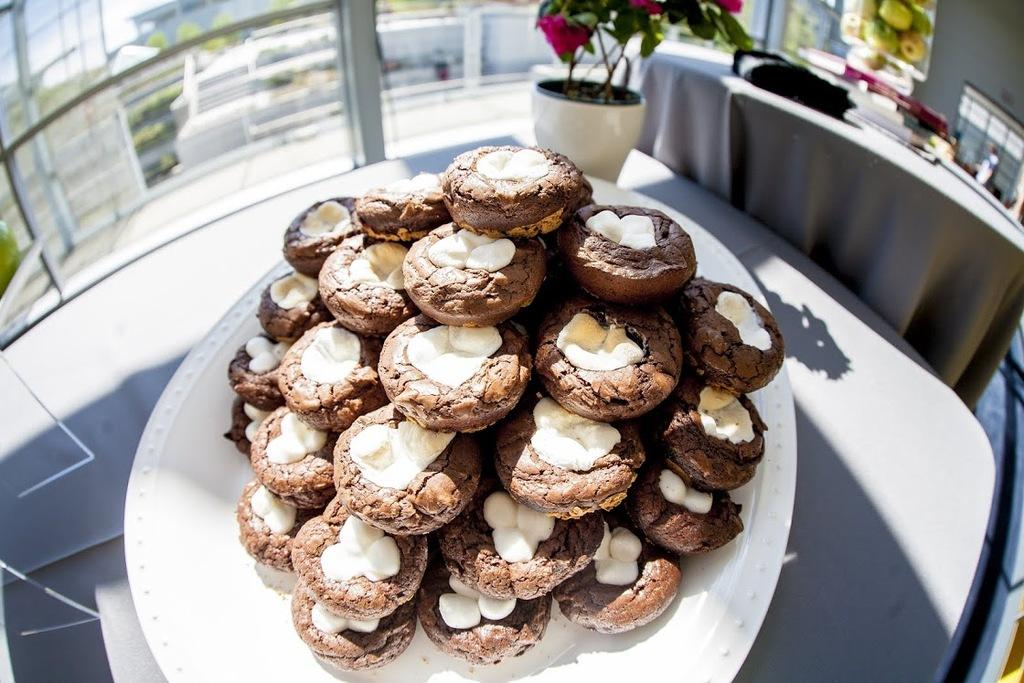What is on the serving plate in the image? The serving plate has cookies placed in rows on it. What else can be seen in the image besides the serving plate? There is a houseplant, a picture on the wall, and tables in the image. Can you describe the arrangement of the cookies on the serving plate? The cookies are placed in rows on the serving plate. What type of decoration or artwork is visible on the wall in the image? The image only mentions that there is a picture on the wall, but it does not provide any details about the content or style of the picture. What is the aftermath of the sleet storm in the image? There is no mention of a sleet storm or any weather-related event in the image. The image only shows a serving plate with cookies, a houseplant, a picture on the wall, and tables. 